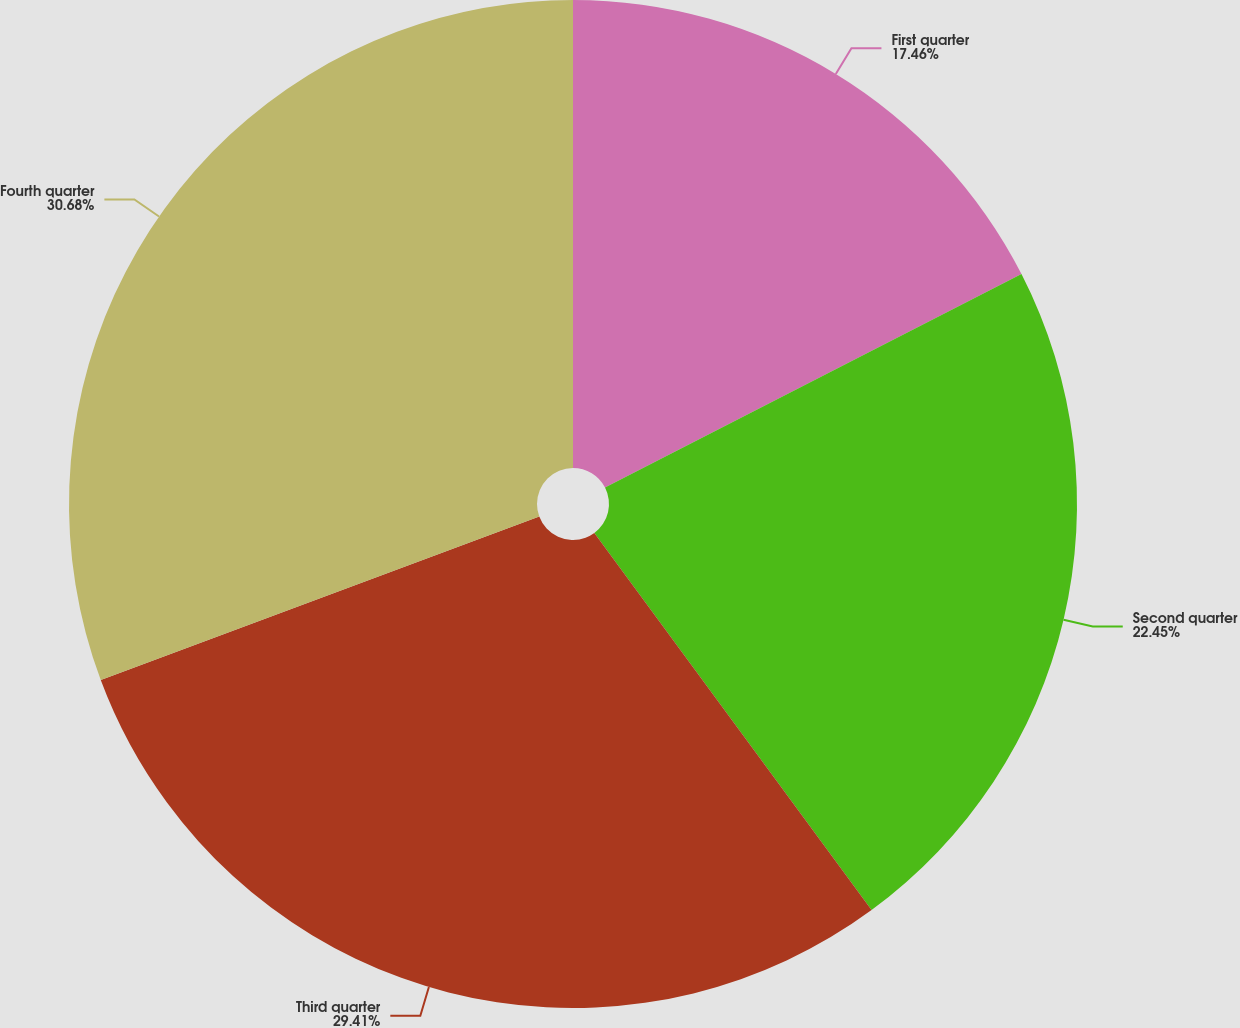Convert chart. <chart><loc_0><loc_0><loc_500><loc_500><pie_chart><fcel>First quarter<fcel>Second quarter<fcel>Third quarter<fcel>Fourth quarter<nl><fcel>17.46%<fcel>22.45%<fcel>29.41%<fcel>30.68%<nl></chart> 